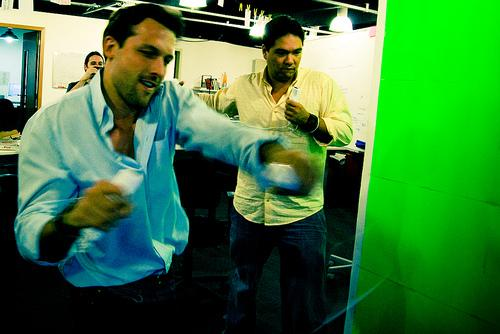What activity is the individual engaging in? gaming 